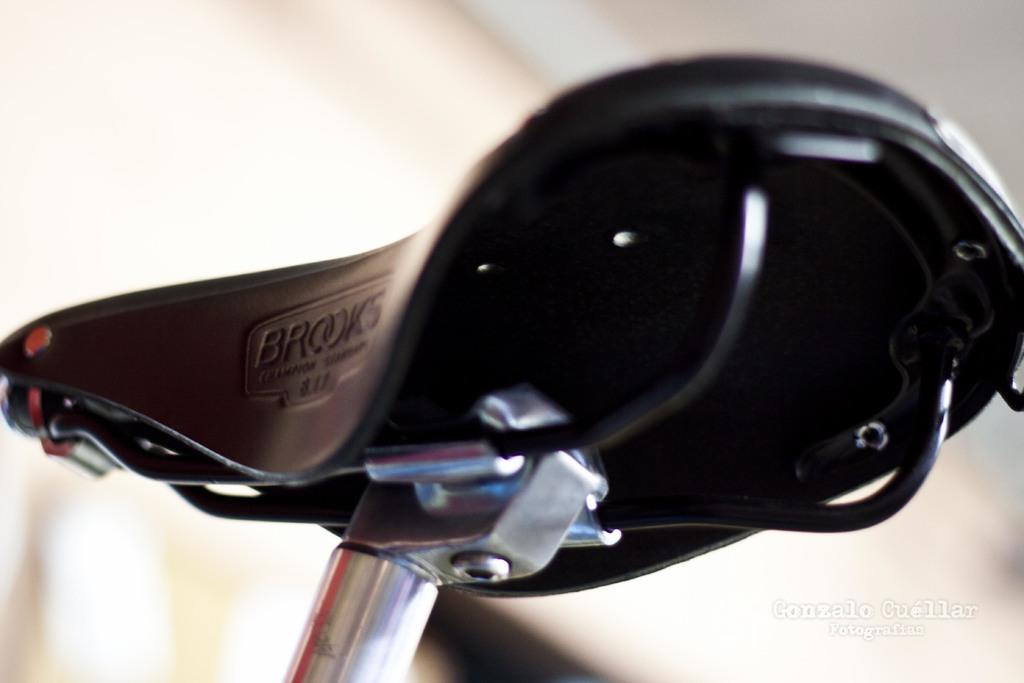What is the main subject in the center of the image? There is a cycle seat in the center of the image. What can be seen in the background of the image? There is a wall in the background of the image. What type of noise can be heard coming from the car in the image? There is no car present in the image, so it is not possible to determine what, if any, noise might be heard. 